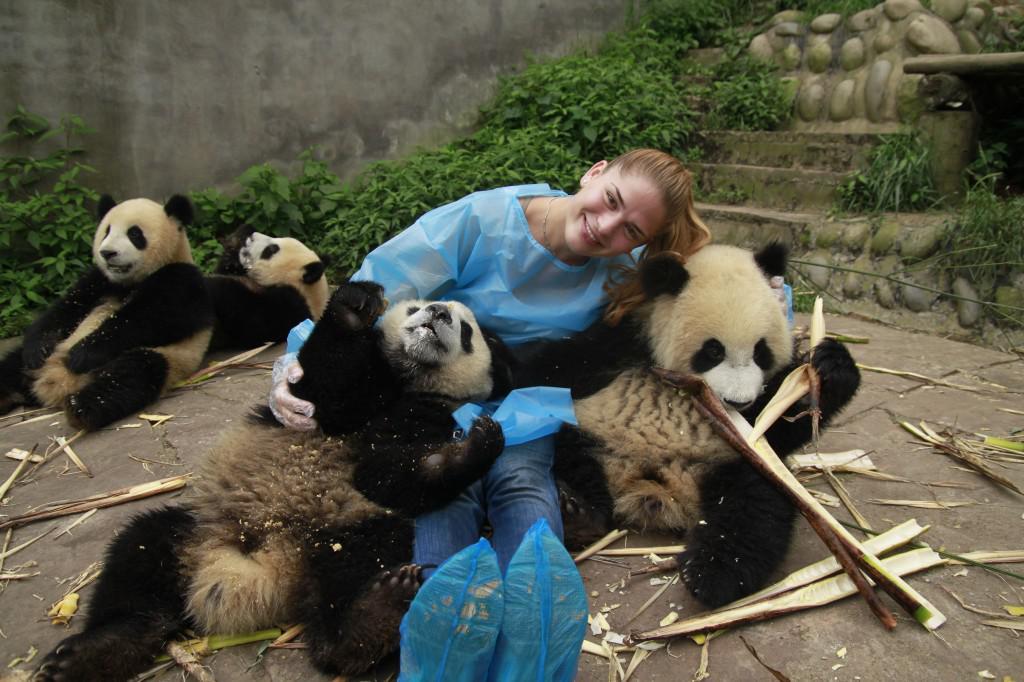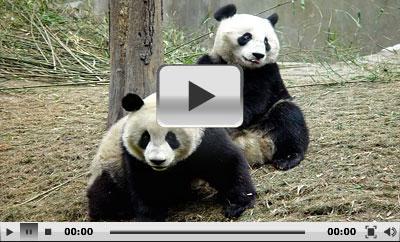The first image is the image on the left, the second image is the image on the right. For the images shown, is this caption "There are no more than four panda bears." true? Answer yes or no. No. The first image is the image on the left, the second image is the image on the right. Given the left and right images, does the statement "No image contains more than three pandas, one image contains a single panda, and a structure made of horizontal wooden poles is pictured in an image." hold true? Answer yes or no. No. 